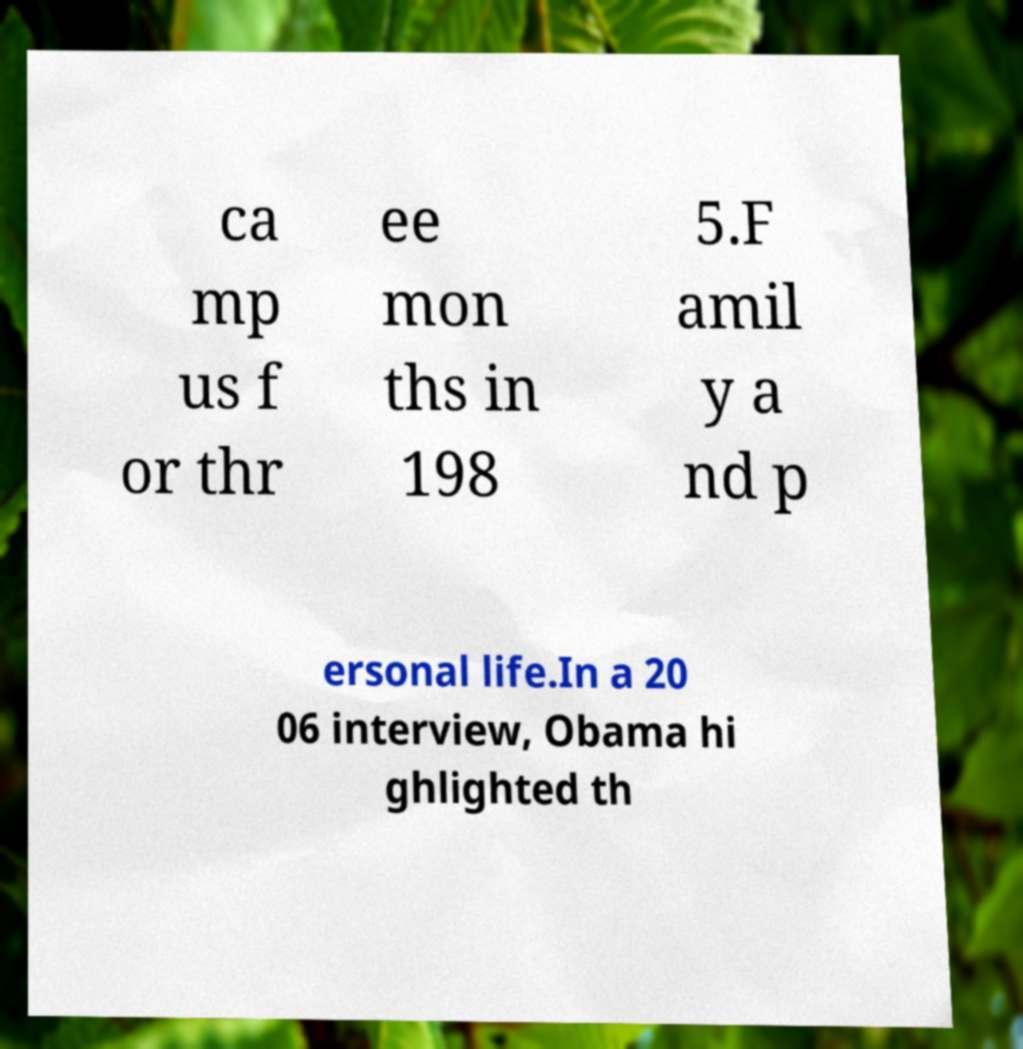Please read and relay the text visible in this image. What does it say? ca mp us f or thr ee mon ths in 198 5.F amil y a nd p ersonal life.In a 20 06 interview, Obama hi ghlighted th 